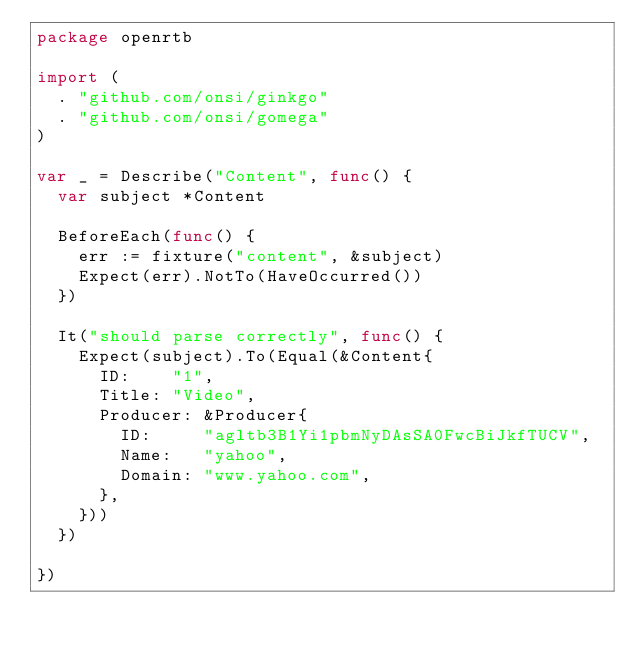<code> <loc_0><loc_0><loc_500><loc_500><_Go_>package openrtb

import (
	. "github.com/onsi/ginkgo"
	. "github.com/onsi/gomega"
)

var _ = Describe("Content", func() {
	var subject *Content

	BeforeEach(func() {
		err := fixture("content", &subject)
		Expect(err).NotTo(HaveOccurred())
	})

	It("should parse correctly", func() {
		Expect(subject).To(Equal(&Content{
			ID:    "1",
			Title: "Video",
			Producer: &Producer{
				ID:     "agltb3B1Yi1pbmNyDAsSA0FwcBiJkfTUCV",
				Name:   "yahoo",
				Domain: "www.yahoo.com",
			},
		}))
	})

})
</code> 